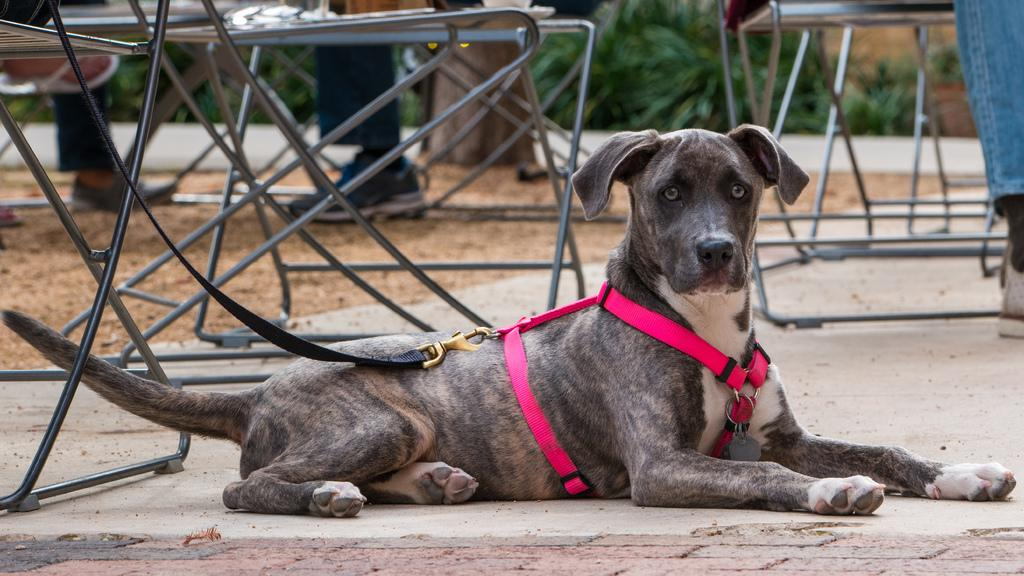What type of animal is in the image? There is a dog in the image. Where is the dog located? The dog is on the ground. What is the dog wearing? The dog is wearing a belt. What can be seen in the background of the image? There are tables and people in the background of the image. What type of vegetation is present in the image? The image includes plants. What type of floor is visible in the image? The image does not show a floor; it shows the dog on the ground outdoors. Can you tell me which wrist the dog is wearing the belt on? The dog is not a human and does not have wrists; it is wearing a belt around its body. 